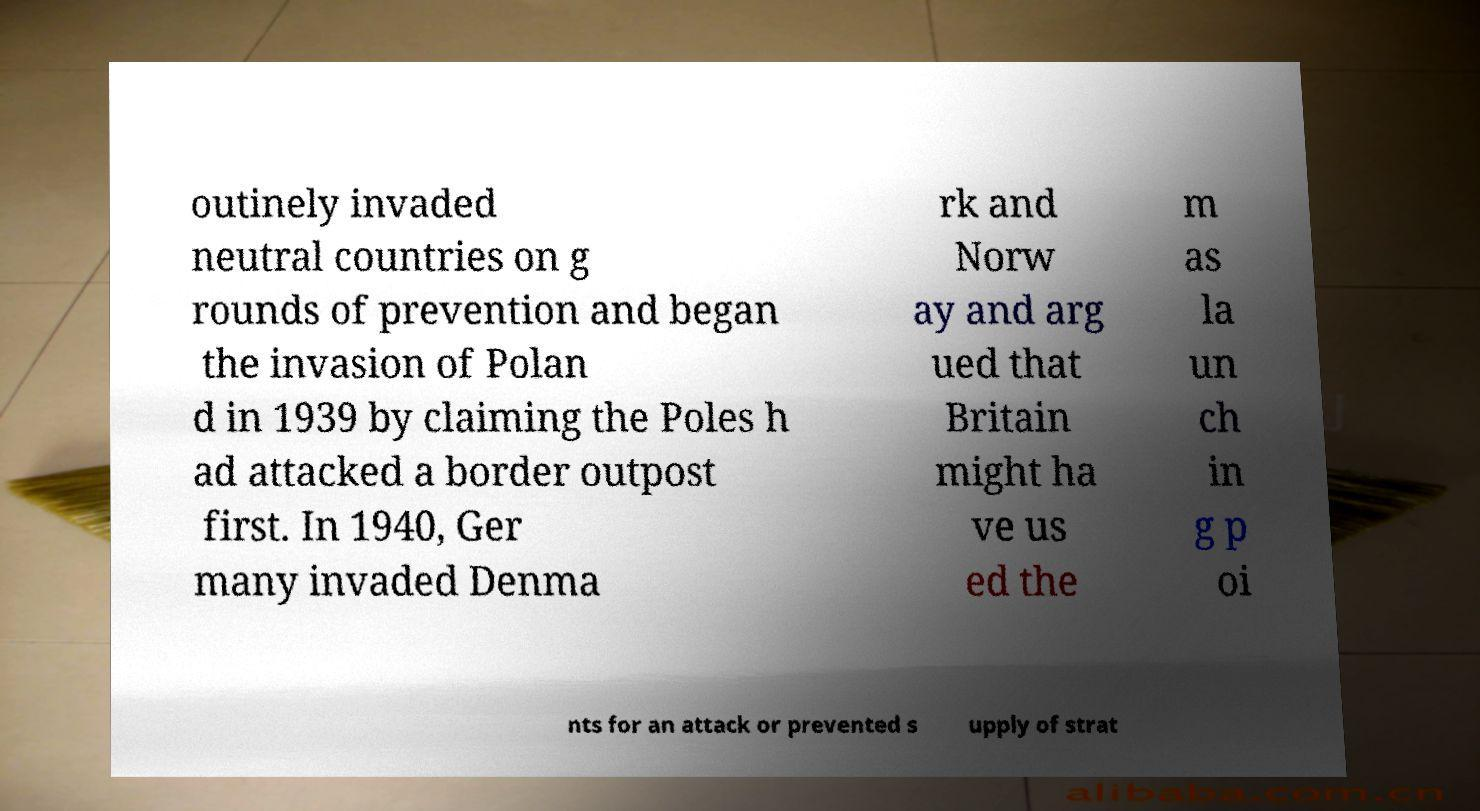Could you assist in decoding the text presented in this image and type it out clearly? outinely invaded neutral countries on g rounds of prevention and began the invasion of Polan d in 1939 by claiming the Poles h ad attacked a border outpost first. In 1940, Ger many invaded Denma rk and Norw ay and arg ued that Britain might ha ve us ed the m as la un ch in g p oi nts for an attack or prevented s upply of strat 